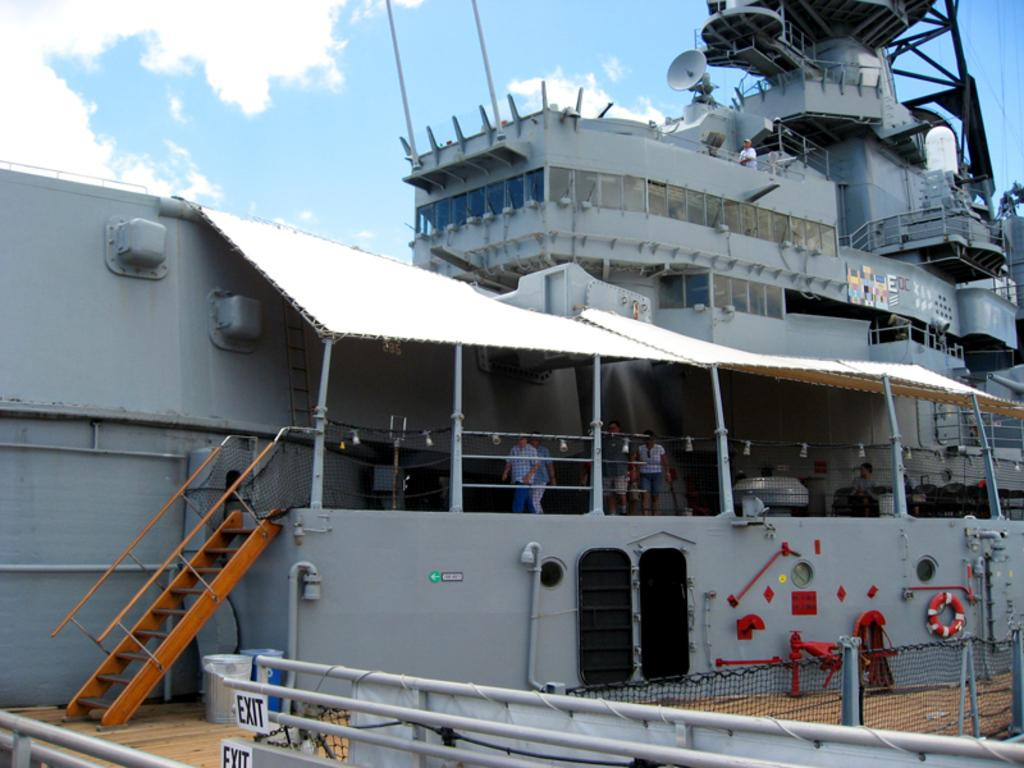<image>
Summarize the visual content of the image. A large grey water vessel has an exit sign on the railing. 